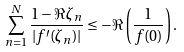Convert formula to latex. <formula><loc_0><loc_0><loc_500><loc_500>\sum _ { n = 1 } ^ { N } \frac { 1 - \Re \zeta _ { n } } { | f ^ { \prime } ( \zeta _ { n } ) | } \leq - \Re \left ( \frac { 1 } { f ( 0 ) } \right ) .</formula> 